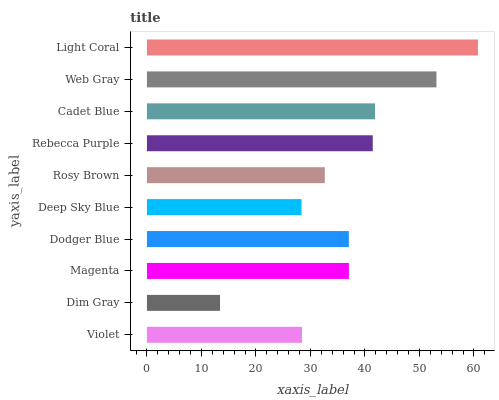Is Dim Gray the minimum?
Answer yes or no. Yes. Is Light Coral the maximum?
Answer yes or no. Yes. Is Magenta the minimum?
Answer yes or no. No. Is Magenta the maximum?
Answer yes or no. No. Is Magenta greater than Dim Gray?
Answer yes or no. Yes. Is Dim Gray less than Magenta?
Answer yes or no. Yes. Is Dim Gray greater than Magenta?
Answer yes or no. No. Is Magenta less than Dim Gray?
Answer yes or no. No. Is Magenta the high median?
Answer yes or no. Yes. Is Dodger Blue the low median?
Answer yes or no. Yes. Is Deep Sky Blue the high median?
Answer yes or no. No. Is Deep Sky Blue the low median?
Answer yes or no. No. 